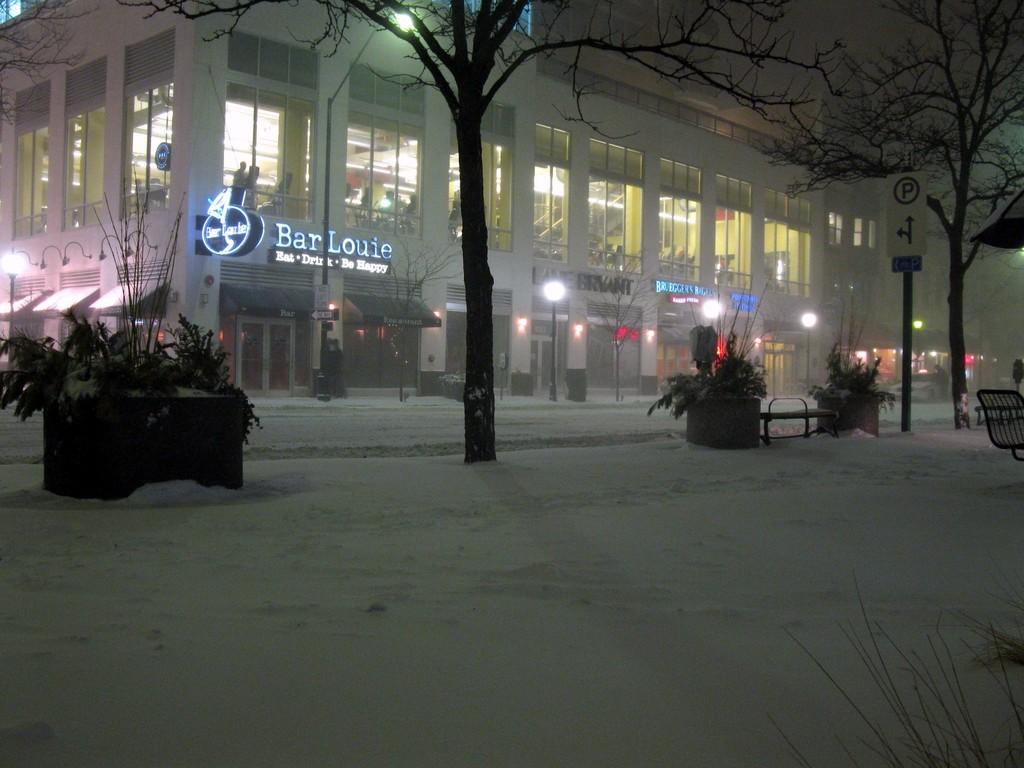What type of structures can be seen in the image? There are buildings in the image. What type of lighting is present in the image? Street lights are present in the image. Can you describe an object attached to a building? There is a board attached to a building. What type of signage is visible in the image? There is a sign board in the image. What type of vegetation can be seen in the image? Plants and trees are visible in the image. Can you describe a piece of outdoor furniture in the image? There is a bench in the image. What other type of seating is present in the image? There is a chair in the image. Where is the queen sitting on the chair in the image? There is no queen present in the image; it only features a chair and other objects mentioned in the facts. What type of hook can be seen holding the house in the image? There is no house or hook present in the image; it only features buildings and other objects mentioned in the facts. 